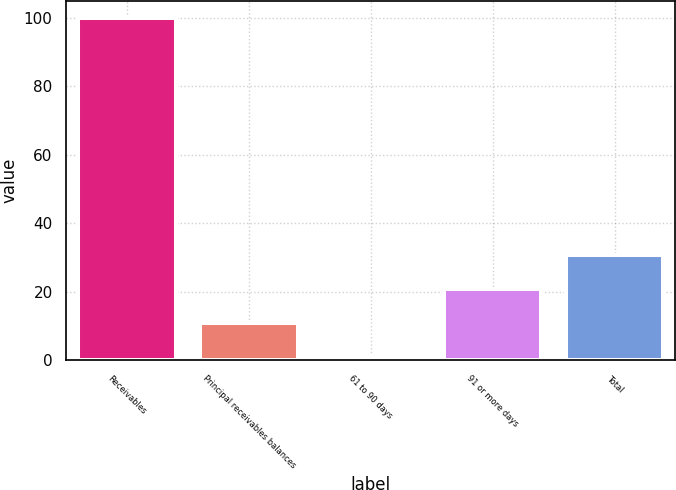<chart> <loc_0><loc_0><loc_500><loc_500><bar_chart><fcel>Receivables<fcel>Principal receivables balances<fcel>61 to 90 days<fcel>91 or more days<fcel>Total<nl><fcel>100<fcel>10.81<fcel>0.9<fcel>20.72<fcel>30.63<nl></chart> 